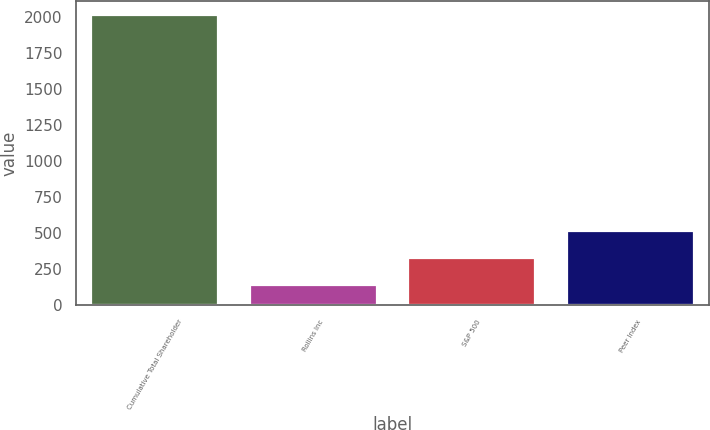Convert chart to OTSL. <chart><loc_0><loc_0><loc_500><loc_500><bar_chart><fcel>Cumulative Total Shareholder<fcel>Rollins Inc<fcel>S&P 500<fcel>Peer Index<nl><fcel>2013<fcel>141.33<fcel>328.5<fcel>515.67<nl></chart> 